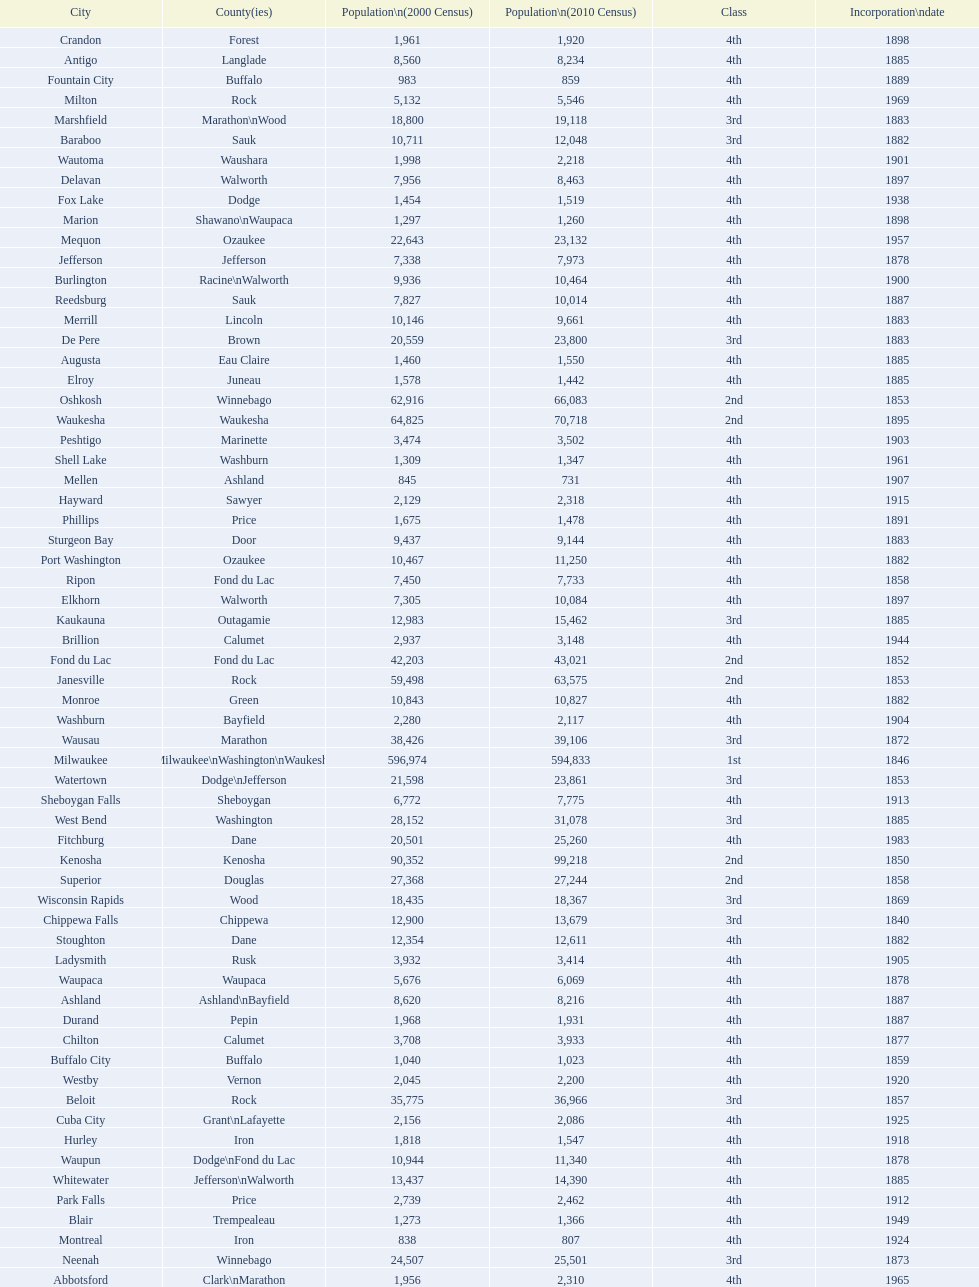County has altoona and augusta? Eau Claire. Would you be able to parse every entry in this table? {'header': ['City', 'County(ies)', 'Population\\n(2000 Census)', 'Population\\n(2010 Census)', 'Class', 'Incorporation\\ndate'], 'rows': [['Crandon', 'Forest', '1,961', '1,920', '4th', '1898'], ['Antigo', 'Langlade', '8,560', '8,234', '4th', '1885'], ['Fountain City', 'Buffalo', '983', '859', '4th', '1889'], ['Milton', 'Rock', '5,132', '5,546', '4th', '1969'], ['Marshfield', 'Marathon\\nWood', '18,800', '19,118', '3rd', '1883'], ['Baraboo', 'Sauk', '10,711', '12,048', '3rd', '1882'], ['Wautoma', 'Waushara', '1,998', '2,218', '4th', '1901'], ['Delavan', 'Walworth', '7,956', '8,463', '4th', '1897'], ['Fox Lake', 'Dodge', '1,454', '1,519', '4th', '1938'], ['Marion', 'Shawano\\nWaupaca', '1,297', '1,260', '4th', '1898'], ['Mequon', 'Ozaukee', '22,643', '23,132', '4th', '1957'], ['Jefferson', 'Jefferson', '7,338', '7,973', '4th', '1878'], ['Burlington', 'Racine\\nWalworth', '9,936', '10,464', '4th', '1900'], ['Reedsburg', 'Sauk', '7,827', '10,014', '4th', '1887'], ['Merrill', 'Lincoln', '10,146', '9,661', '4th', '1883'], ['De Pere', 'Brown', '20,559', '23,800', '3rd', '1883'], ['Augusta', 'Eau Claire', '1,460', '1,550', '4th', '1885'], ['Elroy', 'Juneau', '1,578', '1,442', '4th', '1885'], ['Oshkosh', 'Winnebago', '62,916', '66,083', '2nd', '1853'], ['Waukesha', 'Waukesha', '64,825', '70,718', '2nd', '1895'], ['Peshtigo', 'Marinette', '3,474', '3,502', '4th', '1903'], ['Shell Lake', 'Washburn', '1,309', '1,347', '4th', '1961'], ['Mellen', 'Ashland', '845', '731', '4th', '1907'], ['Hayward', 'Sawyer', '2,129', '2,318', '4th', '1915'], ['Phillips', 'Price', '1,675', '1,478', '4th', '1891'], ['Sturgeon Bay', 'Door', '9,437', '9,144', '4th', '1883'], ['Port Washington', 'Ozaukee', '10,467', '11,250', '4th', '1882'], ['Ripon', 'Fond du Lac', '7,450', '7,733', '4th', '1858'], ['Elkhorn', 'Walworth', '7,305', '10,084', '4th', '1897'], ['Kaukauna', 'Outagamie', '12,983', '15,462', '3rd', '1885'], ['Brillion', 'Calumet', '2,937', '3,148', '4th', '1944'], ['Fond du Lac', 'Fond du Lac', '42,203', '43,021', '2nd', '1852'], ['Janesville', 'Rock', '59,498', '63,575', '2nd', '1853'], ['Monroe', 'Green', '10,843', '10,827', '4th', '1882'], ['Washburn', 'Bayfield', '2,280', '2,117', '4th', '1904'], ['Wausau', 'Marathon', '38,426', '39,106', '3rd', '1872'], ['Milwaukee', 'Milwaukee\\nWashington\\nWaukesha', '596,974', '594,833', '1st', '1846'], ['Watertown', 'Dodge\\nJefferson', '21,598', '23,861', '3rd', '1853'], ['Sheboygan Falls', 'Sheboygan', '6,772', '7,775', '4th', '1913'], ['West Bend', 'Washington', '28,152', '31,078', '3rd', '1885'], ['Fitchburg', 'Dane', '20,501', '25,260', '4th', '1983'], ['Kenosha', 'Kenosha', '90,352', '99,218', '2nd', '1850'], ['Superior', 'Douglas', '27,368', '27,244', '2nd', '1858'], ['Wisconsin Rapids', 'Wood', '18,435', '18,367', '3rd', '1869'], ['Chippewa Falls', 'Chippewa', '12,900', '13,679', '3rd', '1840'], ['Stoughton', 'Dane', '12,354', '12,611', '4th', '1882'], ['Ladysmith', 'Rusk', '3,932', '3,414', '4th', '1905'], ['Waupaca', 'Waupaca', '5,676', '6,069', '4th', '1878'], ['Ashland', 'Ashland\\nBayfield', '8,620', '8,216', '4th', '1887'], ['Durand', 'Pepin', '1,968', '1,931', '4th', '1887'], ['Chilton', 'Calumet', '3,708', '3,933', '4th', '1877'], ['Buffalo City', 'Buffalo', '1,040', '1,023', '4th', '1859'], ['Westby', 'Vernon', '2,045', '2,200', '4th', '1920'], ['Beloit', 'Rock', '35,775', '36,966', '3rd', '1857'], ['Cuba City', 'Grant\\nLafayette', '2,156', '2,086', '4th', '1925'], ['Hurley', 'Iron', '1,818', '1,547', '4th', '1918'], ['Waupun', 'Dodge\\nFond du Lac', '10,944', '11,340', '4th', '1878'], ['Whitewater', 'Jefferson\\nWalworth', '13,437', '14,390', '4th', '1885'], ['Park Falls', 'Price', '2,739', '2,462', '4th', '1912'], ['Blair', 'Trempealeau', '1,273', '1,366', '4th', '1949'], ['Montreal', 'Iron', '838', '807', '4th', '1924'], ['Neenah', 'Winnebago', '24,507', '25,501', '3rd', '1873'], ['Abbotsford', 'Clark\\nMarathon', '1,956', '2,310', '4th', '1965'], ['Juneau', 'Dodge', '2,485', '2,814', '4th', '1887'], ['Chetek', 'Barron', '2,180', '2,221', '4th', '1891'], ['Barron', 'Barron', '3,248', '3,423', '4th', '1887'], ['Mayville', 'Dodge', '4,902', '5,154', '4th', '1885'], ['Seymour', 'Outagamie', '3,335', '3,451', '4th', '1879'], ['Portage', 'Columbia', '9,728', '10,324', '4th', '1854'], ['Schofield', 'Marathon', '2,117', '2,169', '4th', '1951'], ['Hillsboro', 'Vernon', '1,302', '1,417', '4th', '1885'], ['Sheboygan', 'Sheboygan', '50,792', '49,288', '2nd', '1853'], ['Montello', 'Marquette', '1,397', '1,495', '4th', '1938'], ['Hudson', 'St. Croix', '8,775', '12,719', '4th', '1858'], ['Colby', 'Clark\\nMarathon', '1,616', '1,852', '4th', '1891'], ['Tomahawk', 'Lincoln', '3,770', '3,397', '4th', '1891'], ['Eau Claire', 'Chippewa\\nEau Claire', '61,704', '65,883', '2nd', '1872'], ['Clintonville', 'Waupaca', '4,736', '4,559', '4th', '1887'], ['Greenfield', 'Milwaukee', '35,476', '36,720', '3rd', '1957'], ['Greenwood', 'Clark', '1,079', '1,026', '4th', '1891'], ['Beaver Dam', 'Dodge', '15,169', '16,243', '4th', '1856'], ['Tomah', 'Monroe', '8,419', '9,093', '4th', '1883'], ['Viroqua', 'Vernon', '4,335', '5,079', '4th', '1885'], ['Nekoosa', 'Wood', '2,590', '2,580', '4th', '1926'], ['Galesville', 'Trempealeau', '1,427', '1,481', '4th', '1942'], ['Franklin', 'Milwaukee', '29,494', '35,451', '3rd', '1956'], ['Shullsburg', 'Lafayette', '1,246', '1,226', '4th', '1889'], ['Green Lake', 'Green Lake', '1,100', '960', '4th', '1962'], ['Bloomer', 'Chippewa', '3,347', '3,539', '4th', '1920'], ['Rhinelander', 'Oneida', '7,735', '7,798', '4th', '1894'], ['Muskego', 'Waukesha', '21,397', '24,135', '3rd', '1964'], ['Brodhead', 'Green\\nRock', '3,180', '3,293', '4th', '1891'], ['New Holstein', 'Calumet', '3,301', '3,236', '4th', '1889'], ['Kiel', 'Calumet\\nManitowoc', '3,450', '3,738', '4th', '1920'], ['New London', 'Outagamie\\nWaupaca', '7,085', '7,295', '4th', '1877'], ['Berlin', 'Green Lake\\nWaushara', '5,305', '5,524', '4th', '1857'], ['Glendale', 'Milwaukee', '13,367', '12,872', '3rd', '1950'], ['Cudahy', 'Milwaukee', '18,429', '18,267', '3rd', '1906'], ['Racine', 'Racine', '81,855', '78,860', '2nd', '1848'], ['Monona', 'Dane', '8,018', '7,533', '4th', '1969'], ['Lake Geneva', 'Walworth', '7,148', '7,651', '4th', '1883'], ['Madison', 'Dane', '208,054', '233,209', '2nd', '1856'], ['St. Francis', 'Milwaukee', '8,662', '9,365', '4th', '1951'], ['West Allis', 'Milwaukee', '61,254', '60,411', '2nd', '1906'], ['Niagara', 'Marinette', '1,880', '1,624', '4th', '1992'], ['Eagle River', 'Vilas', '1,443', '1,398', '4th', '1937'], ['Owen', 'Clark', '936', '940', '4th', '1925'], ['Osseo', 'Trempealeau', '1,669', '1,701', '4th', '1941'], ['South Milwaukee', 'Milwaukee', '21,256', '21,156', '4th', '1897'], ['Rice Lake', 'Barron', '8,312', '8,438', '4th', '1887'], ['Stevens Point', 'Portage', '24,551', '26,717', '3rd', '1858'], ['Horicon', 'Dodge', '3,775', '3,655', '4th', '1897'], ['Stanley', 'Chippewa\\nClark', '1,898', '3,608', '4th', '1898'], ['La Crosse', 'La Crosse', '51,818', '51,320', '2nd', '1856'], ['Oconto', 'Oconto', '4,708', '4,513', '4th', '1869'], ['Richland Center', 'Richland', '5,114', '5,184', '4th', '1887'], ['Arcadia', 'Trempealeau', '2,402', '2,925', '4th', '1925'], ['Appleton', 'Calumet\\nOutagamie\\nWinnebago', '70,087', '72,623', '2nd', '1857'], ['Mosinee', 'Marathon', '4,063', '3,988', '4th', '1931'], ['Gillett', 'Oconto', '1,262', '1,386', '4th', '1944'], ['Edgerton', 'Dane\\nRock', '4,898', '5,461', '4th', '1883'], ['Delafield', 'Waukesha', '6,472', '7,085', '4th', '1959'], ['Kewaunee', 'Kewaunee', '2,806', '2,952', '4th', '1883'], ['Prairie du Chien', 'Crawford', '6,018', '5,911', '4th', '1872'], ['Weyauwega', 'Waupaca', '1,806', '1,900', '4th', '1939'], ['Oconomowoc', 'Waukesha', '12,382', '15,712', '3rd', '1875'], ['New Lisbon', 'Juneau', '1,436', '2,554', '4th', '1889'], ['Lancaster', 'Grant', '4,070', '3,868', '4th', '1878'], ['Hartford', 'Dodge\\nWashington', '10,905', '14,223', '3rd', '1883'], ['Middleton', 'Dane', '15,770', '17,442', '3rd', '1963'], ['Platteville', 'Grant', '9,989', '11,224', '4th', '1876'], ['Shawano', 'Shawano', '8,298', '9,305', '4th', '1874'], ['Wauwatosa', 'Milwaukee', '47,271', '46,396', '2nd', '1897'], ['New Berlin', 'Waukesha', '38,220', '39,584', '3rd', '1959'], ['Plymouth', 'Sheboygan', '7,781', '8,445', '4th', '1877'], ['Dodgeville', 'Iowa', '4,220', '4,698', '4th', '1889'], ['Independence', 'Trempealeau', '1,244', '1,336', '4th', '1942'], ['Lake Mills', 'Jefferson', '4,843', '5,708', '4th', '1905'], ['Evansville', 'Rock', '4,039', '5,012', '4th', '1896'], ['Thorp', 'Clark', '1,536', '1,621', '4th', '1948'], ['Manitowoc', 'Manitowoc', '34,053', '33,736', '3rd', '1870'], ['Fennimore', 'Grant', '2,387', '2,497', '4th', '1919'], ['Oconto Falls', 'Oconto', '2,843', '2,891', '4th', '1919'], ['Princeton', 'Green Lake', '1,504', '1,214', '4th', '1920'], ['Cornell', 'Chippewa', '1,466', '1,467', '4th', '1956'], ['Algoma', 'Kewaunee', '3,357', '3,167', '4th', '1879'], ['Verona', 'Dane', '7,052', '10,619', '4th', '1977'], ['Loyal', 'Clark', '1,308', '1,261', '4th', '1948'], ['Neillsville', 'Clark', '2,731', '2,463', '4th', '1882'], ['Lodi', 'Columbia', '2,882', '3,050', '4th', '1941'], ['Glenwood City', 'St. Croix', '1,183', '1,242', '4th', '1895'], ['Black River Falls', 'Jackson', '3,618', '3,622', '4th', '1883'], ['Sparta', 'Monroe', '8,648', '9,522', '4th', '1883'], ['New Richmond', 'St. Croix', '6,310', '8,375', '4th', '1885'], ['Adams', 'Adams', '1,831', '1,967', '4th', '1926'], ['Bayfield', 'Bayfield', '611', '487', '4th', '1913'], ['Cedarburg', 'Ozaukee', '11,102', '11,412', '3rd', '1885'], ['Brookfield', 'Waukesha', '38,649', '37,920', '2nd', '1954'], ['Prescott', 'Pierce', '3,764', '4,258', '4th', '1857'], ['Waterloo', 'Jefferson', '3,259', '3,333', '4th', '1962'], ['Green Bay', 'Brown', '102,767', '104,057', '2nd', '1854'], ['Columbus', 'Columbia\\nDodge', '4,479', '4,991', '4th', '1874'], ['Oak Creek', 'Milwaukee', '28,456', '34,451', '3rd', '1955'], ['Mondovi', 'Buffalo', '2,634', '2,777', '4th', '1889'], ['Two Rivers', 'Manitowoc', '12,639', '11,712', '3rd', '1878'], ['Boscobel', 'Grant', '3,047', '3,231', '4th', '1873'], ['Darlington', 'Lafayette', '2,418', '2,451', '4th', '1877'], ['Spooner', 'Washburn', '2,653', '2,682', '4th', '1909'], ['Cumberland', 'Barron', '2,280', '2,170', '4th', '1885'], ['Alma', 'Buffalo', '942', '781', '4th', '1885'], ['Sun Prairie', 'Dane', '20,369', '29,364', '3rd', '1958'], ['Onalaska', 'La Crosse', '14,839', '17,736', '4th', '1887'], ['Markesan', 'Green Lake', '1,396', '1,476', '4th', '1959'], ['Menasha', 'Calumet\\nWinnebago', '16,331', '17,353', '3rd', '1874'], ['Omro', 'Winnebago', '3,177', '3,517', '4th', '1944'], ['St. Croix Falls', 'Polk', '2,033', '2,133', '4th', '1958'], ['Pittsville', 'Wood', '866', '874', '4th', '1887'], ['Pewaukee', 'Waukesha', '11,783', '13,195', '3rd', '1999'], ['Whitehall', 'Trempealeau', '1,651', '1,558', '4th', '1941'], ['Altoona', 'Eau Claire', '6,698', '6,706', '4th', '1887'], ['Mauston', 'Juneau', '3,740', '4,423', '4th', '1883'], ['Manawa', 'Waupaca', '1,330', '1,371', '4th', '1954'], ['Fort Atkinson', 'Jefferson', '11,621', '12,368', '4th', '1878'], ['Menomonie', 'Dunn', '14,937', '16,264', '4th', '1882'], ['Amery', 'Polk', '2,845', '2,902', '4th', '1919'], ['Wisconsin Dells', 'Adams\\nColumbia\\nJuneau\\nSauk', '2,418', '2,678', '4th', '1925'], ['Mineral Point', 'Iowa', '2,617', '2,487', '4th', '1857'], ['Medford', 'Taylor', '4,350', '4,326', '4th', '1889'], ['Marinette', 'Marinette', '11,749', '10,968', '3rd', '1887'], ['River Falls', 'Pierce\\nSt. Croix', '12,560', '15,000', '3rd', '1875']]} 